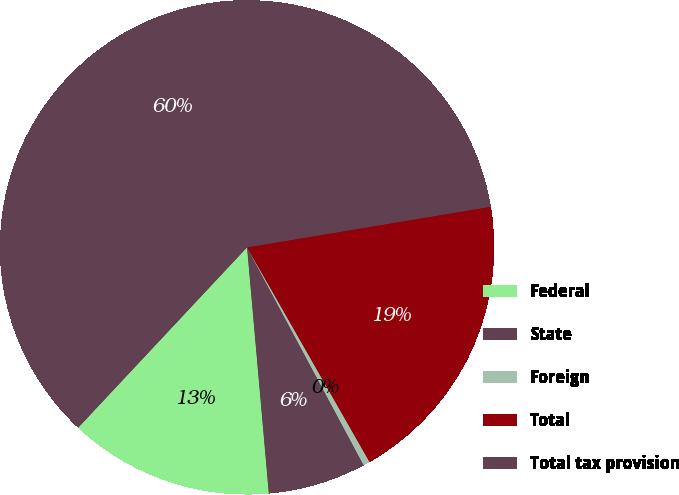Convert chart to OTSL. <chart><loc_0><loc_0><loc_500><loc_500><pie_chart><fcel>Federal<fcel>State<fcel>Foreign<fcel>Total<fcel>Total tax provision<nl><fcel>13.38%<fcel>6.42%<fcel>0.43%<fcel>19.38%<fcel>60.39%<nl></chart> 